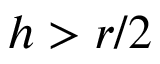Convert formula to latex. <formula><loc_0><loc_0><loc_500><loc_500>h > r / 2</formula> 